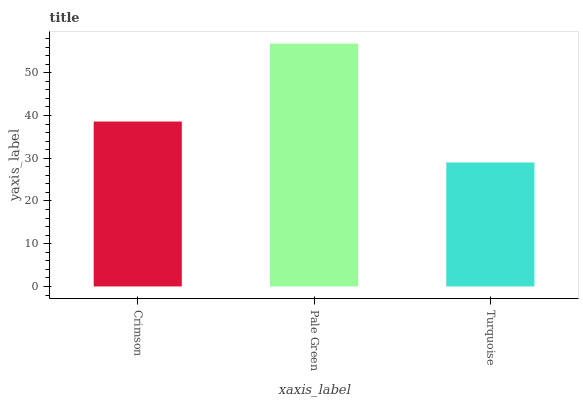Is Turquoise the minimum?
Answer yes or no. Yes. Is Pale Green the maximum?
Answer yes or no. Yes. Is Pale Green the minimum?
Answer yes or no. No. Is Turquoise the maximum?
Answer yes or no. No. Is Pale Green greater than Turquoise?
Answer yes or no. Yes. Is Turquoise less than Pale Green?
Answer yes or no. Yes. Is Turquoise greater than Pale Green?
Answer yes or no. No. Is Pale Green less than Turquoise?
Answer yes or no. No. Is Crimson the high median?
Answer yes or no. Yes. Is Crimson the low median?
Answer yes or no. Yes. Is Pale Green the high median?
Answer yes or no. No. Is Turquoise the low median?
Answer yes or no. No. 